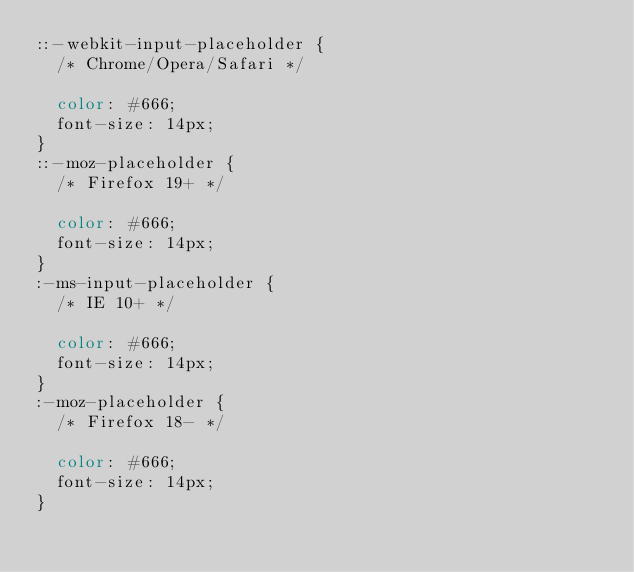<code> <loc_0><loc_0><loc_500><loc_500><_CSS_>::-webkit-input-placeholder {
  /* Chrome/Opera/Safari */

  color: #666;
  font-size: 14px;
}
::-moz-placeholder {
  /* Firefox 19+ */

  color: #666;
  font-size: 14px;
}
:-ms-input-placeholder {
  /* IE 10+ */

  color: #666;
  font-size: 14px;
}
:-moz-placeholder {
  /* Firefox 18- */

  color: #666;
  font-size: 14px;
}
</code> 